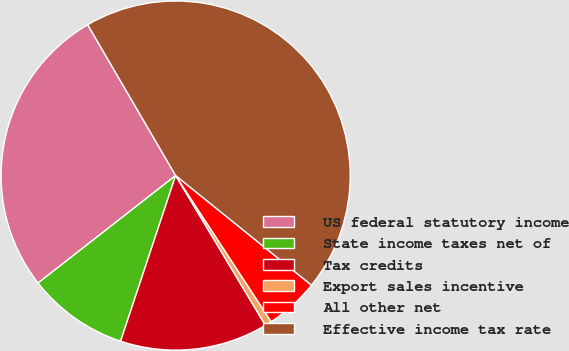<chart> <loc_0><loc_0><loc_500><loc_500><pie_chart><fcel>US federal statutory income<fcel>State income taxes net of<fcel>Tax credits<fcel>Export sales incentive<fcel>All other net<fcel>Effective income tax rate<nl><fcel>27.15%<fcel>9.34%<fcel>13.7%<fcel>0.62%<fcel>4.98%<fcel>44.21%<nl></chart> 